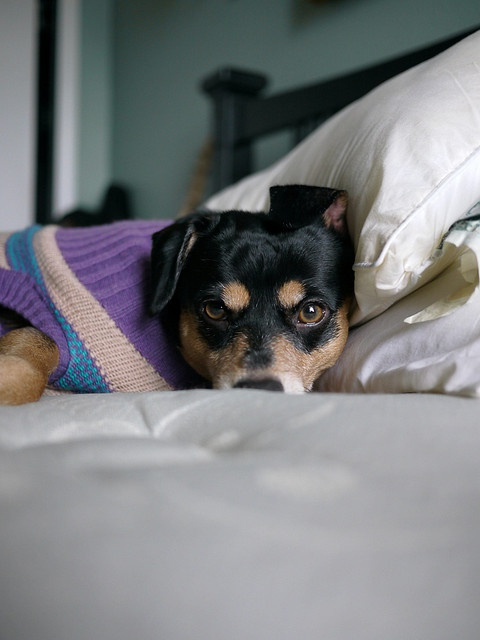Describe the objects in this image and their specific colors. I can see bed in gray, darkgray, lightgray, and black tones and dog in gray, black, purple, and darkgray tones in this image. 